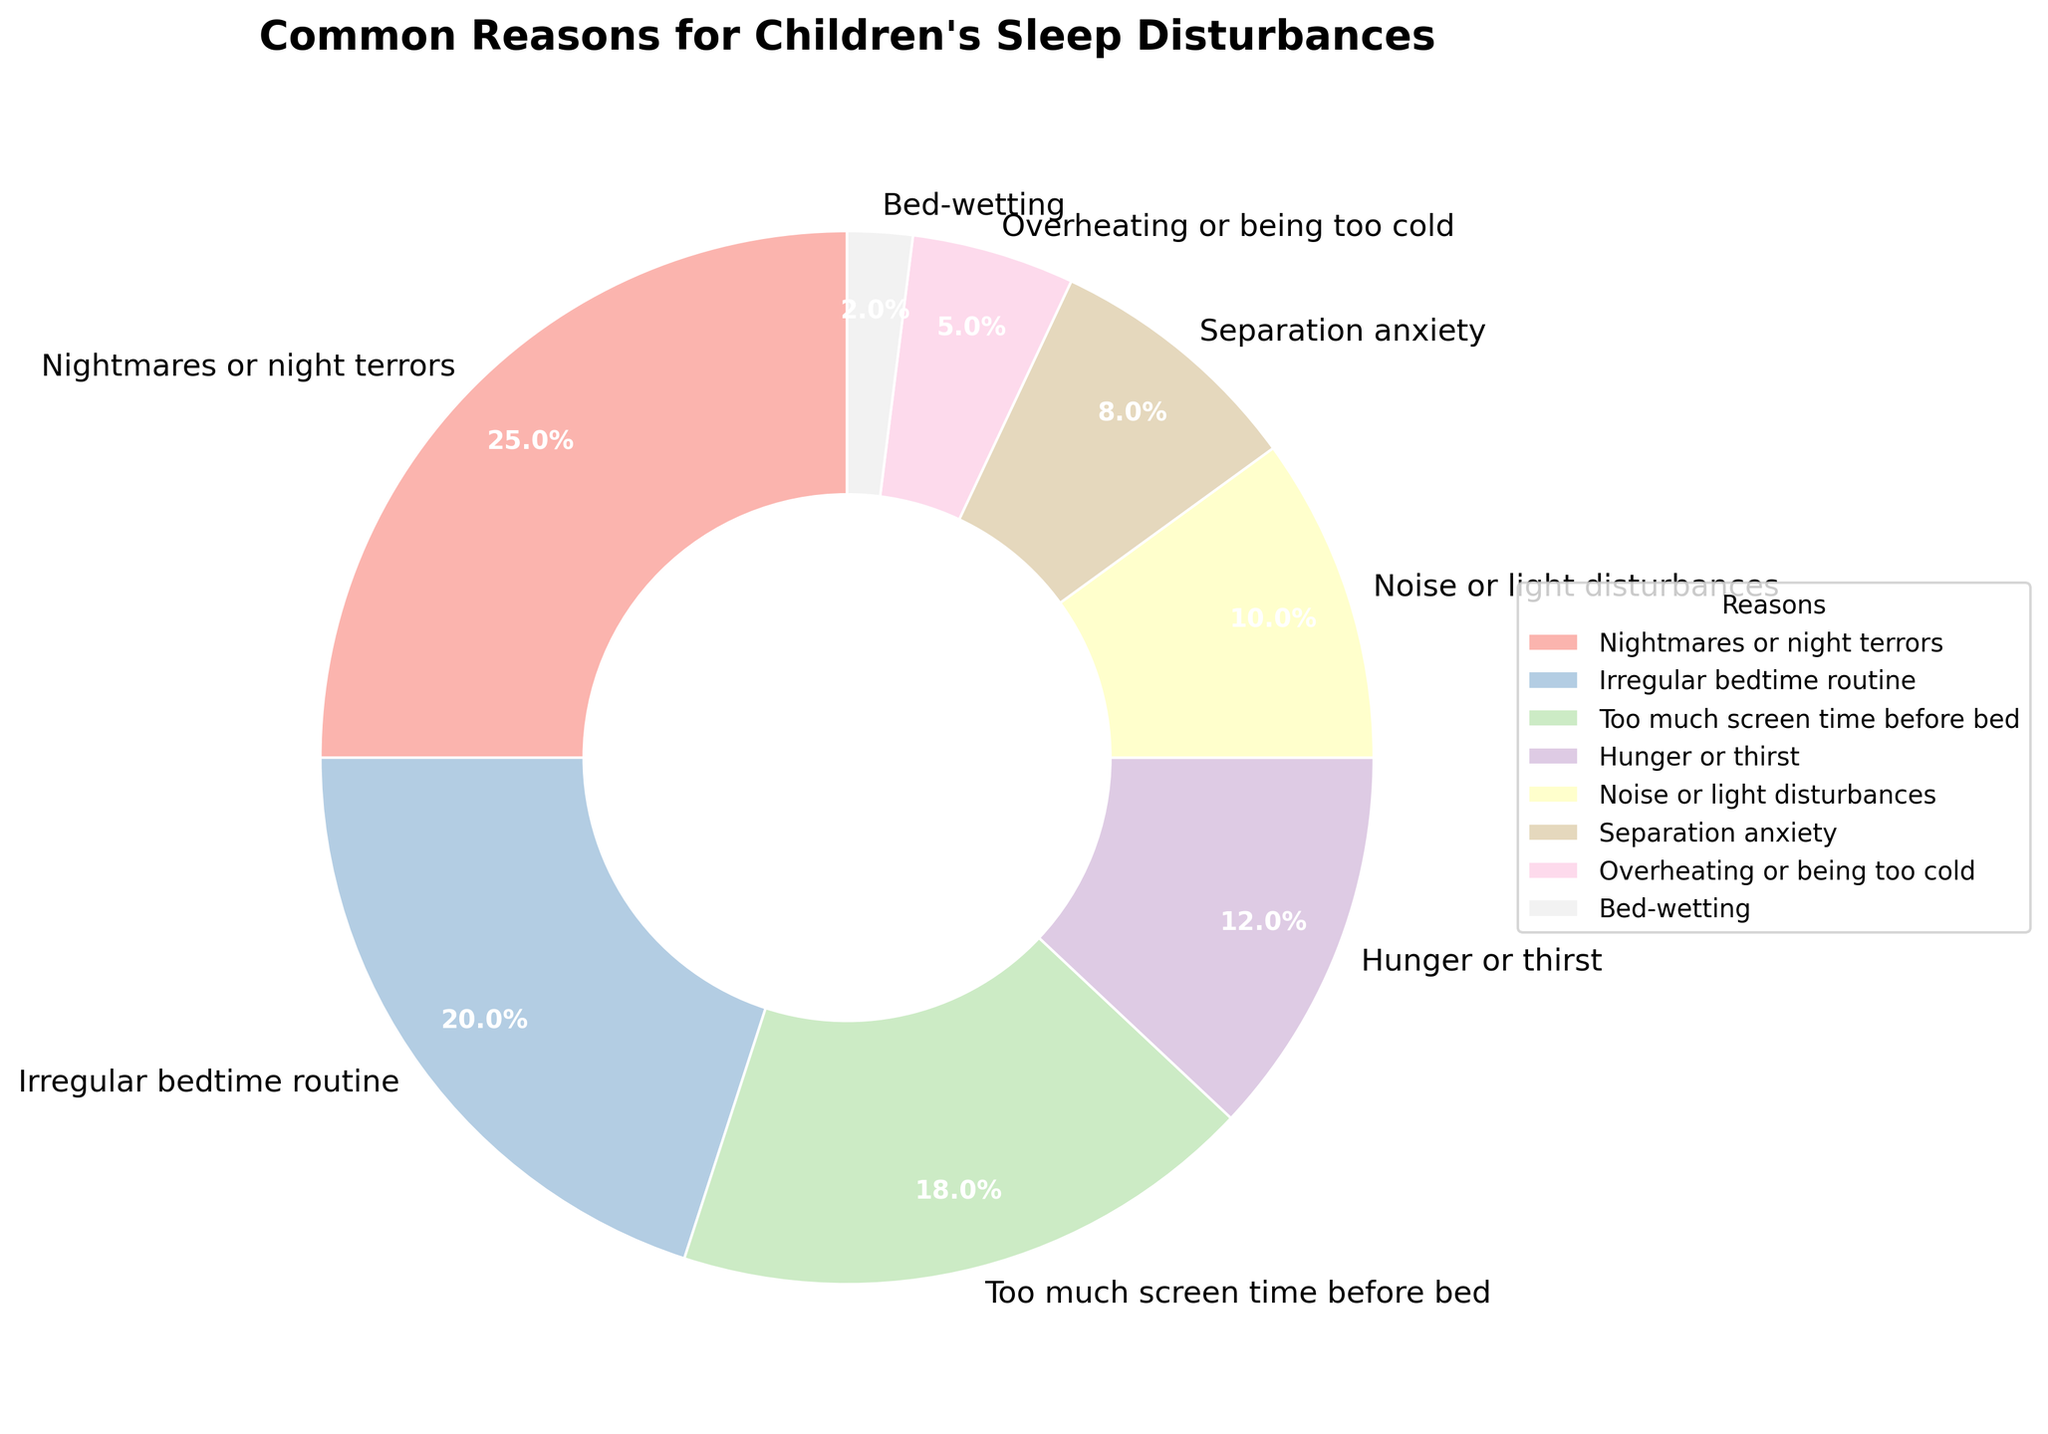What is the most common reason for children's sleep disturbances? The largest section of the pie chart represents nightmares or night terrors with a percentage of 25%.
Answer: Nightmares or night terrors Which reason has a percentage that is exactly 2% lower than "Irregular bedtime routine"? "Too much screen time before bed" has a percentage of 18%, which is 2% lower than "Irregular bedtime routine" at 20%.
Answer: Too much screen time before bed What is the combined percentage of "Hunger or thirst" and "Noise or light disturbances"? "Hunger or thirst" is 12% and "Noise or light disturbances" is 10%. Adding these together, 12% + 10% equals 22%.
Answer: 22% Which is more common, "Separation anxiety" or "Overheating or being too cold"? "Separation anxiety" has a percentage of 8%, while "Overheating or being too cold" has a percentage of 5%, making "Separation anxiety" more common.
Answer: Separation anxiety What is the combined percentage of the three least common reasons? The three least common reasons are "Bed-wetting" at 2%, "Overheating or being too cold" at 5%, and "Separation anxiety" at 8%. Adding these together, 2% + 5% + 8% equals 15%.
Answer: 15% Identify the section colored in lightest pastel shade. The legend linking colors to reasons shows that "Bed-wetting" is associated with the lightest pastel shade.
Answer: Bed-wetting By how much is "Nightmares or night terrors" more common than "Too much screen time before bed"? "Nightmares or night terrors" is 25% and "Too much screen time before bed" is 18%. Subtracting these, 25% - 18% equals 7%.
Answer: 7% Which reason for sleep disturbances has the third-highest percentage? Analyzing the pie chart, the third-highest percentage is 18% which corresponds to "Too much screen time before bed".
Answer: Too much screen time before bed What percentage of children's sleep disturbances are caused by either "Irregular bedtime routine" or "Noise or light disturbances"? "Irregular bedtime routine" is 20% and "Noise or light disturbances" is 10%. Adding these together, 20% + 10% equals 30%.
Answer: 30% What is the difference in percentage between "Hunger or thirst" and "Separation anxiety"? "Hunger or thirst" is 12% and "Separation anxiety" is 8%. Subtracting these, 12% - 8% equals 4%.
Answer: 4% 